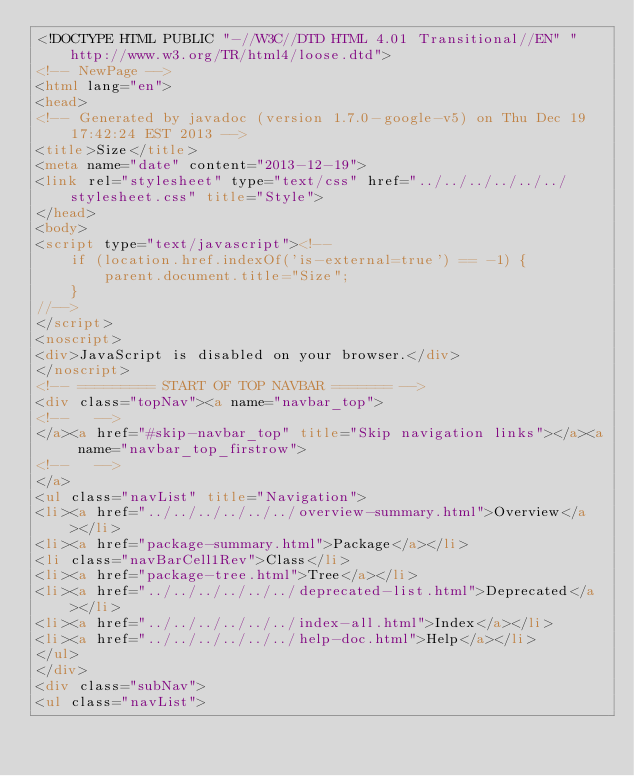<code> <loc_0><loc_0><loc_500><loc_500><_HTML_><!DOCTYPE HTML PUBLIC "-//W3C//DTD HTML 4.01 Transitional//EN" "http://www.w3.org/TR/html4/loose.dtd">
<!-- NewPage -->
<html lang="en">
<head>
<!-- Generated by javadoc (version 1.7.0-google-v5) on Thu Dec 19 17:42:24 EST 2013 -->
<title>Size</title>
<meta name="date" content="2013-12-19">
<link rel="stylesheet" type="text/css" href="../../../../../../stylesheet.css" title="Style">
</head>
<body>
<script type="text/javascript"><!--
    if (location.href.indexOf('is-external=true') == -1) {
        parent.document.title="Size";
    }
//-->
</script>
<noscript>
<div>JavaScript is disabled on your browser.</div>
</noscript>
<!-- ========= START OF TOP NAVBAR ======= -->
<div class="topNav"><a name="navbar_top">
<!--   -->
</a><a href="#skip-navbar_top" title="Skip navigation links"></a><a name="navbar_top_firstrow">
<!--   -->
</a>
<ul class="navList" title="Navigation">
<li><a href="../../../../../../overview-summary.html">Overview</a></li>
<li><a href="package-summary.html">Package</a></li>
<li class="navBarCell1Rev">Class</li>
<li><a href="package-tree.html">Tree</a></li>
<li><a href="../../../../../../deprecated-list.html">Deprecated</a></li>
<li><a href="../../../../../../index-all.html">Index</a></li>
<li><a href="../../../../../../help-doc.html">Help</a></li>
</ul>
</div>
<div class="subNav">
<ul class="navList"></code> 